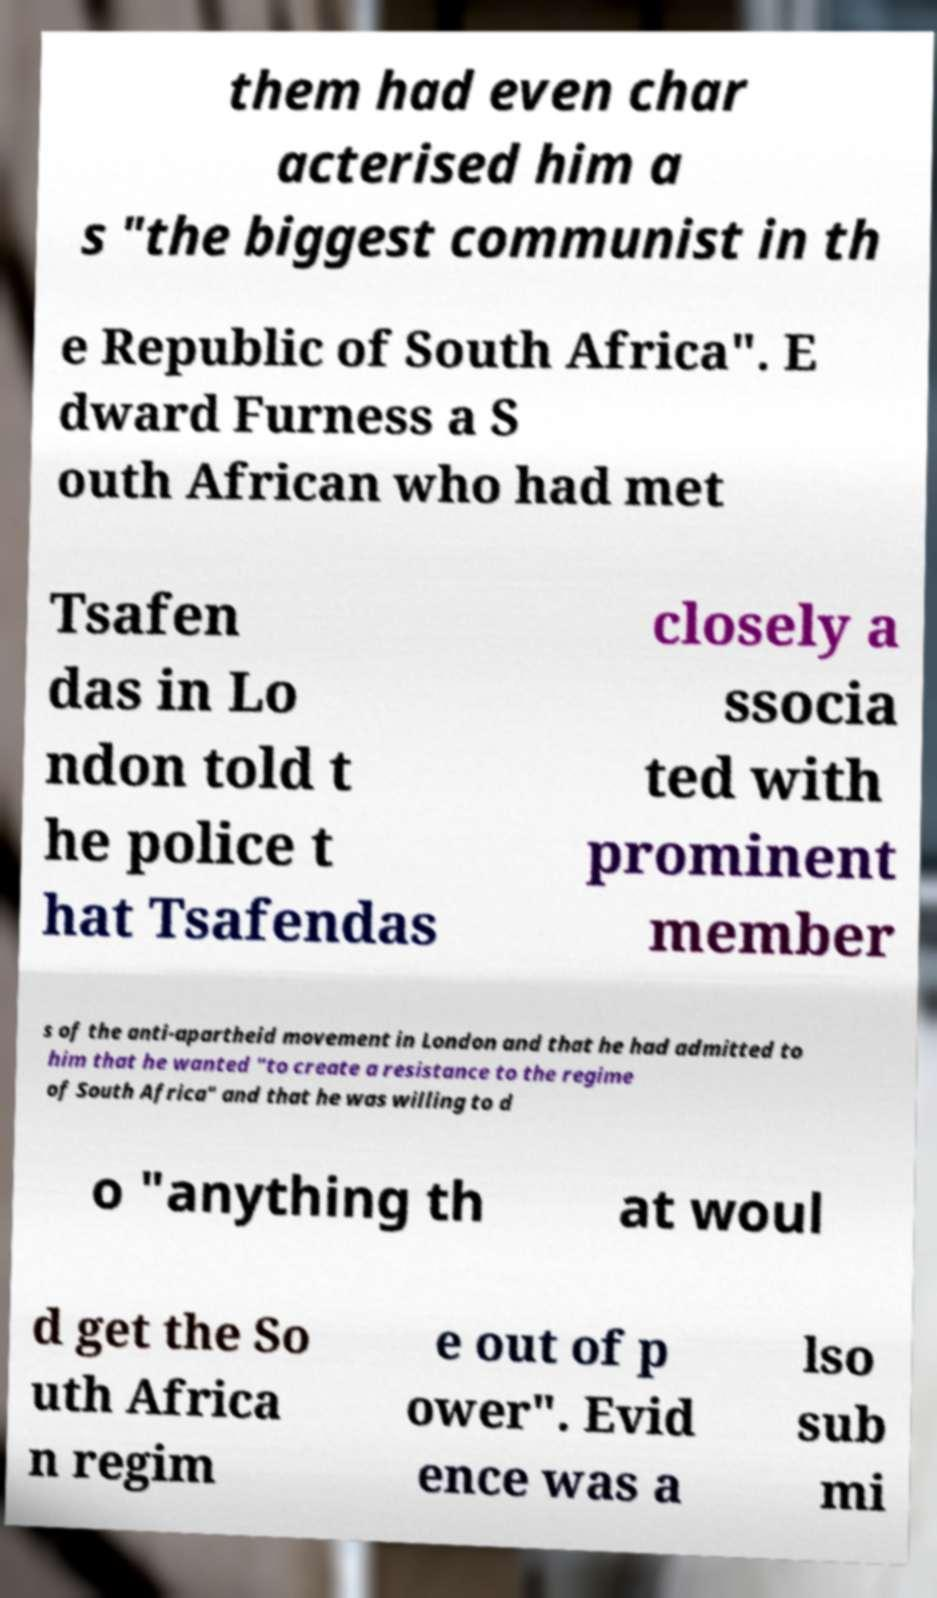I need the written content from this picture converted into text. Can you do that? them had even char acterised him a s "the biggest communist in th e Republic of South Africa". E dward Furness a S outh African who had met Tsafen das in Lo ndon told t he police t hat Tsafendas closely a ssocia ted with prominent member s of the anti-apartheid movement in London and that he had admitted to him that he wanted "to create a resistance to the regime of South Africa" and that he was willing to d o "anything th at woul d get the So uth Africa n regim e out of p ower". Evid ence was a lso sub mi 